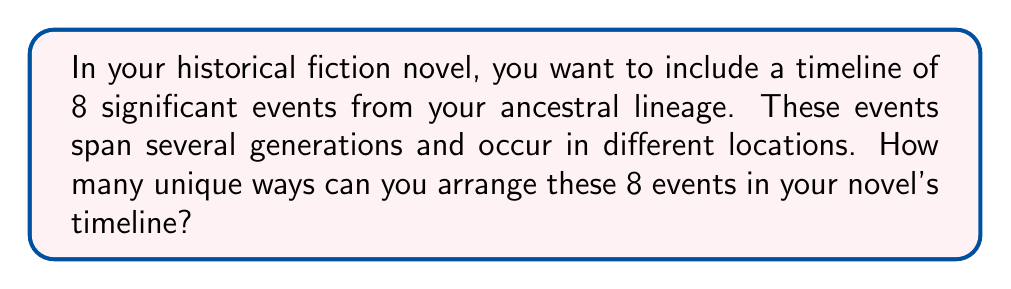What is the answer to this math problem? To solve this problem, we need to consider the concept of permutations. In this case, we are arranging all 8 events in a specific order, and each event can only be used once.

The number of permutations of $n$ distinct objects is given by the formula:

$$P(n) = n!$$

Where $n!$ (n factorial) is the product of all positive integers less than or equal to $n$.

In this case, we have 8 events to arrange, so $n = 8$.

Therefore, the number of unique ways to arrange the 8 events is:

$$P(8) = 8!$$

Let's calculate this:

$$\begin{align}
8! &= 8 \times 7 \times 6 \times 5 \times 4 \times 3 \times 2 \times 1 \\
   &= 40,320
\end{align}$$

This means there are 40,320 different ways to arrange the 8 historical events in your novel's timeline.

As an author, this large number of possibilities allows you great flexibility in structuring your narrative. You can choose the arrangement that best suits your storytelling needs, whether you want to present events chronologically or in a more complex, non-linear fashion to create suspense or highlight thematic connections between different generations.
Answer: $40,320$ unique ways 